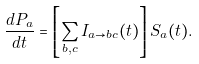Convert formula to latex. <formula><loc_0><loc_0><loc_500><loc_500>\frac { d P _ { a } } { d t } = \left [ \sum _ { b , c } I _ { a \rightarrow b c } ( t ) \right ] S _ { a } ( t ) .</formula> 